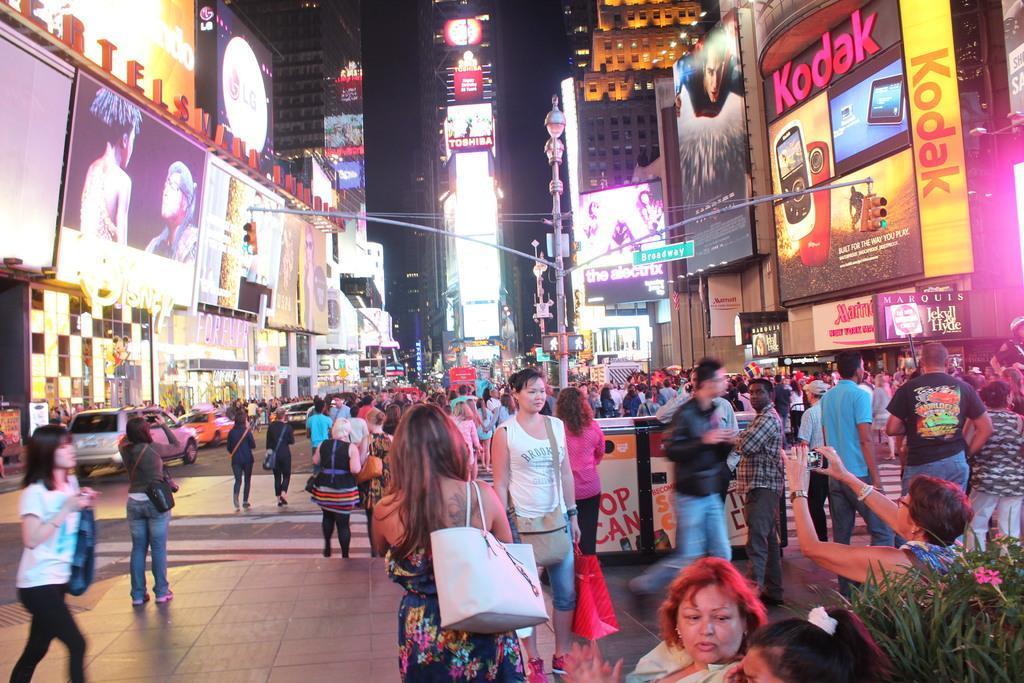Please provide a concise description of this image. In this image I see number of people and all of them are on the path and I see few of them are sitting and there is a plant over here. In the background I see the buildings on which there are few screens and few hoardings and I can also see few poles and vehicles over here. 